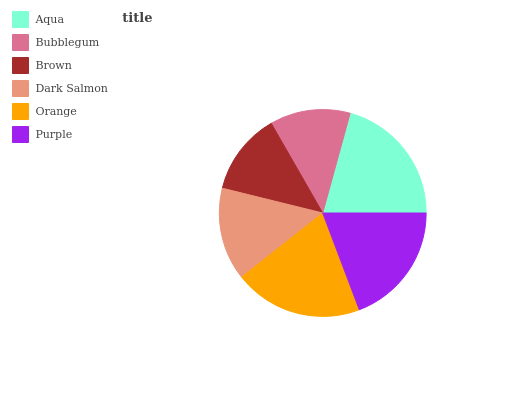Is Bubblegum the minimum?
Answer yes or no. Yes. Is Aqua the maximum?
Answer yes or no. Yes. Is Brown the minimum?
Answer yes or no. No. Is Brown the maximum?
Answer yes or no. No. Is Brown greater than Bubblegum?
Answer yes or no. Yes. Is Bubblegum less than Brown?
Answer yes or no. Yes. Is Bubblegum greater than Brown?
Answer yes or no. No. Is Brown less than Bubblegum?
Answer yes or no. No. Is Purple the high median?
Answer yes or no. Yes. Is Dark Salmon the low median?
Answer yes or no. Yes. Is Bubblegum the high median?
Answer yes or no. No. Is Purple the low median?
Answer yes or no. No. 